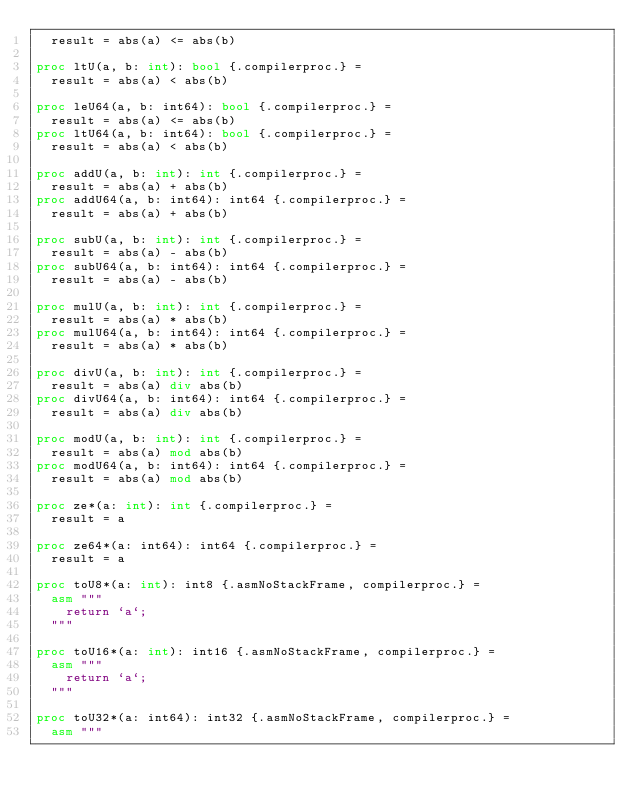<code> <loc_0><loc_0><loc_500><loc_500><_Nim_>  result = abs(a) <= abs(b)

proc ltU(a, b: int): bool {.compilerproc.} =
  result = abs(a) < abs(b)

proc leU64(a, b: int64): bool {.compilerproc.} =
  result = abs(a) <= abs(b)
proc ltU64(a, b: int64): bool {.compilerproc.} =
  result = abs(a) < abs(b)

proc addU(a, b: int): int {.compilerproc.} =
  result = abs(a) + abs(b)
proc addU64(a, b: int64): int64 {.compilerproc.} =
  result = abs(a) + abs(b)

proc subU(a, b: int): int {.compilerproc.} =
  result = abs(a) - abs(b)
proc subU64(a, b: int64): int64 {.compilerproc.} =
  result = abs(a) - abs(b)

proc mulU(a, b: int): int {.compilerproc.} =
  result = abs(a) * abs(b)
proc mulU64(a, b: int64): int64 {.compilerproc.} =
  result = abs(a) * abs(b)

proc divU(a, b: int): int {.compilerproc.} =
  result = abs(a) div abs(b)
proc divU64(a, b: int64): int64 {.compilerproc.} =
  result = abs(a) div abs(b)

proc modU(a, b: int): int {.compilerproc.} =
  result = abs(a) mod abs(b)
proc modU64(a, b: int64): int64 {.compilerproc.} =
  result = abs(a) mod abs(b)

proc ze*(a: int): int {.compilerproc.} =
  result = a

proc ze64*(a: int64): int64 {.compilerproc.} =
  result = a

proc toU8*(a: int): int8 {.asmNoStackFrame, compilerproc.} =
  asm """
    return `a`;
  """

proc toU16*(a: int): int16 {.asmNoStackFrame, compilerproc.} =
  asm """
    return `a`;
  """

proc toU32*(a: int64): int32 {.asmNoStackFrame, compilerproc.} =
  asm """</code> 